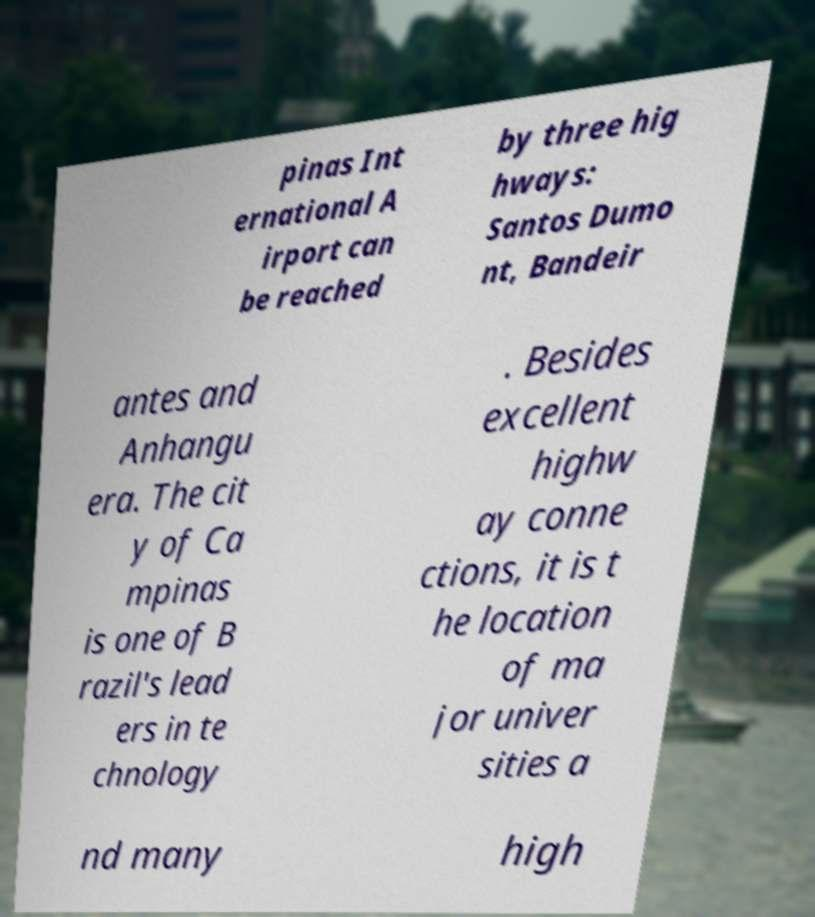Please read and relay the text visible in this image. What does it say? pinas Int ernational A irport can be reached by three hig hways: Santos Dumo nt, Bandeir antes and Anhangu era. The cit y of Ca mpinas is one of B razil's lead ers in te chnology . Besides excellent highw ay conne ctions, it is t he location of ma jor univer sities a nd many high 